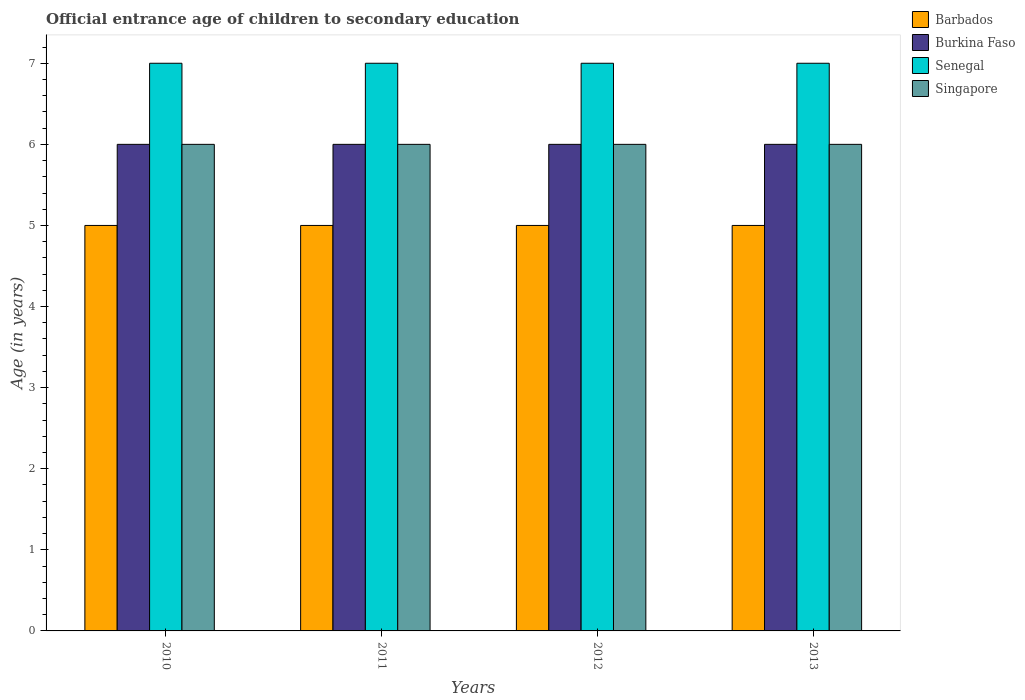How many different coloured bars are there?
Keep it short and to the point. 4. Are the number of bars per tick equal to the number of legend labels?
Your response must be concise. Yes. Are the number of bars on each tick of the X-axis equal?
Provide a succinct answer. Yes. How many bars are there on the 2nd tick from the right?
Offer a terse response. 4. What is the secondary school starting age of children in Senegal in 2010?
Your answer should be compact. 7. Across all years, what is the minimum secondary school starting age of children in Burkina Faso?
Ensure brevity in your answer.  6. In which year was the secondary school starting age of children in Burkina Faso maximum?
Your answer should be very brief. 2010. In which year was the secondary school starting age of children in Barbados minimum?
Your answer should be very brief. 2010. What is the total secondary school starting age of children in Burkina Faso in the graph?
Provide a short and direct response. 24. What is the difference between the secondary school starting age of children in Senegal in 2010 and that in 2012?
Your answer should be very brief. 0. What is the difference between the secondary school starting age of children in Burkina Faso in 2010 and the secondary school starting age of children in Singapore in 2013?
Offer a very short reply. 0. What is the average secondary school starting age of children in Singapore per year?
Make the answer very short. 6. In the year 2010, what is the difference between the secondary school starting age of children in Burkina Faso and secondary school starting age of children in Senegal?
Make the answer very short. -1. In how many years, is the secondary school starting age of children in Singapore greater than 0.8 years?
Give a very brief answer. 4. What is the ratio of the secondary school starting age of children in Singapore in 2011 to that in 2013?
Give a very brief answer. 1. What is the difference between the highest and the second highest secondary school starting age of children in Senegal?
Keep it short and to the point. 0. In how many years, is the secondary school starting age of children in Burkina Faso greater than the average secondary school starting age of children in Burkina Faso taken over all years?
Provide a succinct answer. 0. Is it the case that in every year, the sum of the secondary school starting age of children in Barbados and secondary school starting age of children in Singapore is greater than the sum of secondary school starting age of children in Senegal and secondary school starting age of children in Burkina Faso?
Your answer should be very brief. No. What does the 3rd bar from the left in 2013 represents?
Provide a succinct answer. Senegal. What does the 4th bar from the right in 2012 represents?
Your response must be concise. Barbados. Is it the case that in every year, the sum of the secondary school starting age of children in Senegal and secondary school starting age of children in Burkina Faso is greater than the secondary school starting age of children in Singapore?
Your answer should be very brief. Yes. Are all the bars in the graph horizontal?
Ensure brevity in your answer.  No. How many years are there in the graph?
Ensure brevity in your answer.  4. Where does the legend appear in the graph?
Your answer should be compact. Top right. How are the legend labels stacked?
Offer a terse response. Vertical. What is the title of the graph?
Provide a short and direct response. Official entrance age of children to secondary education. What is the label or title of the Y-axis?
Your answer should be very brief. Age (in years). What is the Age (in years) of Singapore in 2010?
Ensure brevity in your answer.  6. What is the Age (in years) in Burkina Faso in 2011?
Keep it short and to the point. 6. What is the Age (in years) in Senegal in 2012?
Your answer should be very brief. 7. What is the Age (in years) in Singapore in 2012?
Make the answer very short. 6. What is the Age (in years) of Barbados in 2013?
Offer a very short reply. 5. What is the Age (in years) of Burkina Faso in 2013?
Provide a succinct answer. 6. What is the Age (in years) of Senegal in 2013?
Your answer should be very brief. 7. What is the Age (in years) of Singapore in 2013?
Offer a very short reply. 6. Across all years, what is the maximum Age (in years) in Senegal?
Your response must be concise. 7. Across all years, what is the maximum Age (in years) of Singapore?
Make the answer very short. 6. Across all years, what is the minimum Age (in years) of Burkina Faso?
Keep it short and to the point. 6. Across all years, what is the minimum Age (in years) in Singapore?
Offer a very short reply. 6. What is the total Age (in years) in Barbados in the graph?
Provide a short and direct response. 20. What is the total Age (in years) in Senegal in the graph?
Give a very brief answer. 28. What is the total Age (in years) in Singapore in the graph?
Your answer should be compact. 24. What is the difference between the Age (in years) of Senegal in 2010 and that in 2011?
Give a very brief answer. 0. What is the difference between the Age (in years) of Barbados in 2010 and that in 2012?
Your answer should be very brief. 0. What is the difference between the Age (in years) in Burkina Faso in 2010 and that in 2012?
Keep it short and to the point. 0. What is the difference between the Age (in years) of Senegal in 2010 and that in 2012?
Provide a succinct answer. 0. What is the difference between the Age (in years) in Barbados in 2011 and that in 2012?
Offer a terse response. 0. What is the difference between the Age (in years) in Burkina Faso in 2011 and that in 2012?
Your answer should be compact. 0. What is the difference between the Age (in years) in Burkina Faso in 2011 and that in 2013?
Make the answer very short. 0. What is the difference between the Age (in years) in Senegal in 2011 and that in 2013?
Keep it short and to the point. 0. What is the difference between the Age (in years) of Singapore in 2011 and that in 2013?
Give a very brief answer. 0. What is the difference between the Age (in years) of Barbados in 2012 and that in 2013?
Give a very brief answer. 0. What is the difference between the Age (in years) in Burkina Faso in 2010 and the Age (in years) in Senegal in 2011?
Offer a terse response. -1. What is the difference between the Age (in years) in Senegal in 2010 and the Age (in years) in Singapore in 2011?
Your answer should be very brief. 1. What is the difference between the Age (in years) of Barbados in 2010 and the Age (in years) of Senegal in 2012?
Give a very brief answer. -2. What is the difference between the Age (in years) of Burkina Faso in 2010 and the Age (in years) of Senegal in 2012?
Your answer should be very brief. -1. What is the difference between the Age (in years) of Burkina Faso in 2010 and the Age (in years) of Singapore in 2012?
Provide a short and direct response. 0. What is the difference between the Age (in years) in Senegal in 2010 and the Age (in years) in Singapore in 2012?
Offer a terse response. 1. What is the difference between the Age (in years) of Barbados in 2010 and the Age (in years) of Burkina Faso in 2013?
Provide a succinct answer. -1. What is the difference between the Age (in years) in Barbados in 2011 and the Age (in years) in Burkina Faso in 2012?
Provide a succinct answer. -1. What is the difference between the Age (in years) in Barbados in 2011 and the Age (in years) in Singapore in 2012?
Ensure brevity in your answer.  -1. What is the difference between the Age (in years) in Senegal in 2011 and the Age (in years) in Singapore in 2012?
Keep it short and to the point. 1. What is the difference between the Age (in years) of Barbados in 2011 and the Age (in years) of Burkina Faso in 2013?
Offer a terse response. -1. What is the difference between the Age (in years) of Barbados in 2011 and the Age (in years) of Senegal in 2013?
Your answer should be very brief. -2. What is the difference between the Age (in years) of Barbados in 2011 and the Age (in years) of Singapore in 2013?
Provide a short and direct response. -1. What is the difference between the Age (in years) of Burkina Faso in 2011 and the Age (in years) of Senegal in 2013?
Keep it short and to the point. -1. What is the difference between the Age (in years) of Burkina Faso in 2011 and the Age (in years) of Singapore in 2013?
Make the answer very short. 0. What is the difference between the Age (in years) in Barbados in 2012 and the Age (in years) in Burkina Faso in 2013?
Your answer should be very brief. -1. What is the difference between the Age (in years) in Burkina Faso in 2012 and the Age (in years) in Singapore in 2013?
Make the answer very short. 0. What is the average Age (in years) in Barbados per year?
Your answer should be compact. 5. What is the average Age (in years) in Burkina Faso per year?
Offer a terse response. 6. What is the average Age (in years) in Senegal per year?
Your answer should be compact. 7. What is the average Age (in years) in Singapore per year?
Keep it short and to the point. 6. In the year 2010, what is the difference between the Age (in years) of Barbados and Age (in years) of Burkina Faso?
Offer a very short reply. -1. In the year 2010, what is the difference between the Age (in years) in Burkina Faso and Age (in years) in Senegal?
Give a very brief answer. -1. In the year 2010, what is the difference between the Age (in years) in Burkina Faso and Age (in years) in Singapore?
Your response must be concise. 0. In the year 2011, what is the difference between the Age (in years) in Barbados and Age (in years) in Burkina Faso?
Give a very brief answer. -1. In the year 2012, what is the difference between the Age (in years) in Barbados and Age (in years) in Burkina Faso?
Your answer should be very brief. -1. In the year 2012, what is the difference between the Age (in years) of Barbados and Age (in years) of Senegal?
Your response must be concise. -2. In the year 2013, what is the difference between the Age (in years) of Barbados and Age (in years) of Senegal?
Offer a very short reply. -2. In the year 2013, what is the difference between the Age (in years) in Barbados and Age (in years) in Singapore?
Ensure brevity in your answer.  -1. In the year 2013, what is the difference between the Age (in years) in Senegal and Age (in years) in Singapore?
Offer a very short reply. 1. What is the ratio of the Age (in years) of Barbados in 2010 to that in 2011?
Provide a short and direct response. 1. What is the ratio of the Age (in years) in Burkina Faso in 2010 to that in 2011?
Provide a short and direct response. 1. What is the ratio of the Age (in years) of Singapore in 2010 to that in 2011?
Keep it short and to the point. 1. What is the ratio of the Age (in years) in Barbados in 2010 to that in 2012?
Your response must be concise. 1. What is the ratio of the Age (in years) of Burkina Faso in 2010 to that in 2012?
Your response must be concise. 1. What is the ratio of the Age (in years) of Singapore in 2010 to that in 2012?
Your answer should be compact. 1. What is the ratio of the Age (in years) of Burkina Faso in 2010 to that in 2013?
Your answer should be very brief. 1. What is the ratio of the Age (in years) of Senegal in 2010 to that in 2013?
Your answer should be compact. 1. What is the ratio of the Age (in years) in Singapore in 2010 to that in 2013?
Your answer should be compact. 1. What is the ratio of the Age (in years) in Burkina Faso in 2011 to that in 2012?
Your response must be concise. 1. What is the ratio of the Age (in years) of Senegal in 2011 to that in 2012?
Make the answer very short. 1. What is the ratio of the Age (in years) of Senegal in 2011 to that in 2013?
Make the answer very short. 1. What is the ratio of the Age (in years) in Barbados in 2012 to that in 2013?
Ensure brevity in your answer.  1. What is the ratio of the Age (in years) of Burkina Faso in 2012 to that in 2013?
Keep it short and to the point. 1. What is the difference between the highest and the second highest Age (in years) of Senegal?
Offer a very short reply. 0. What is the difference between the highest and the lowest Age (in years) of Burkina Faso?
Keep it short and to the point. 0. What is the difference between the highest and the lowest Age (in years) in Senegal?
Make the answer very short. 0. 